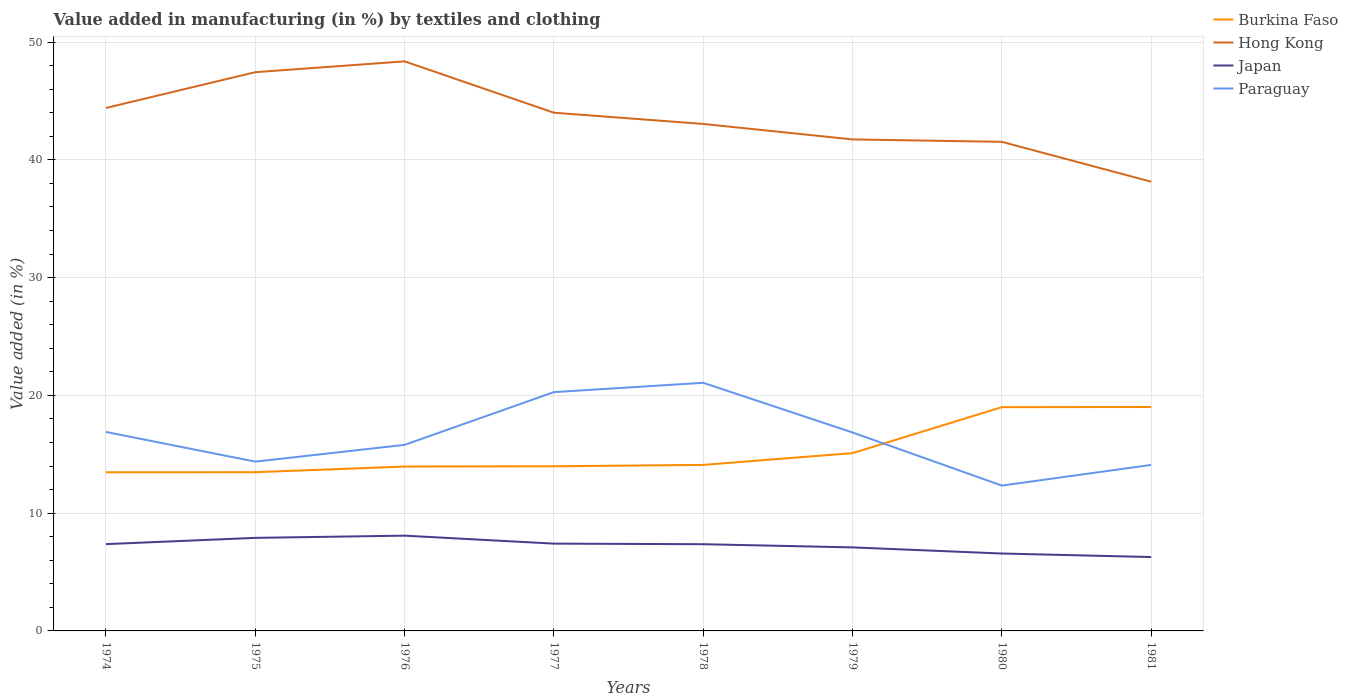How many different coloured lines are there?
Give a very brief answer. 4. Does the line corresponding to Hong Kong intersect with the line corresponding to Japan?
Provide a succinct answer. No. Across all years, what is the maximum percentage of value added in manufacturing by textiles and clothing in Paraguay?
Keep it short and to the point. 12.34. What is the total percentage of value added in manufacturing by textiles and clothing in Burkina Faso in the graph?
Keep it short and to the point. -5.53. What is the difference between the highest and the second highest percentage of value added in manufacturing by textiles and clothing in Hong Kong?
Your response must be concise. 10.22. What is the difference between the highest and the lowest percentage of value added in manufacturing by textiles and clothing in Hong Kong?
Offer a very short reply. 4. Is the percentage of value added in manufacturing by textiles and clothing in Japan strictly greater than the percentage of value added in manufacturing by textiles and clothing in Hong Kong over the years?
Your response must be concise. Yes. How many lines are there?
Provide a short and direct response. 4. How many years are there in the graph?
Make the answer very short. 8. What is the difference between two consecutive major ticks on the Y-axis?
Your answer should be compact. 10. Are the values on the major ticks of Y-axis written in scientific E-notation?
Give a very brief answer. No. How are the legend labels stacked?
Provide a short and direct response. Vertical. What is the title of the graph?
Make the answer very short. Value added in manufacturing (in %) by textiles and clothing. Does "Lower middle income" appear as one of the legend labels in the graph?
Offer a terse response. No. What is the label or title of the X-axis?
Your response must be concise. Years. What is the label or title of the Y-axis?
Offer a very short reply. Value added (in %). What is the Value added (in %) of Burkina Faso in 1974?
Keep it short and to the point. 13.47. What is the Value added (in %) in Hong Kong in 1974?
Provide a short and direct response. 44.41. What is the Value added (in %) of Japan in 1974?
Your answer should be very brief. 7.37. What is the Value added (in %) in Paraguay in 1974?
Keep it short and to the point. 16.9. What is the Value added (in %) of Burkina Faso in 1975?
Give a very brief answer. 13.48. What is the Value added (in %) in Hong Kong in 1975?
Offer a terse response. 47.44. What is the Value added (in %) of Japan in 1975?
Your answer should be very brief. 7.9. What is the Value added (in %) in Paraguay in 1975?
Provide a short and direct response. 14.38. What is the Value added (in %) in Burkina Faso in 1976?
Keep it short and to the point. 13.96. What is the Value added (in %) of Hong Kong in 1976?
Give a very brief answer. 48.36. What is the Value added (in %) in Japan in 1976?
Your response must be concise. 8.09. What is the Value added (in %) in Paraguay in 1976?
Your answer should be very brief. 15.8. What is the Value added (in %) of Burkina Faso in 1977?
Ensure brevity in your answer.  13.98. What is the Value added (in %) in Hong Kong in 1977?
Your answer should be compact. 44. What is the Value added (in %) of Japan in 1977?
Ensure brevity in your answer.  7.41. What is the Value added (in %) of Paraguay in 1977?
Ensure brevity in your answer.  20.28. What is the Value added (in %) of Burkina Faso in 1978?
Your answer should be very brief. 14.1. What is the Value added (in %) of Hong Kong in 1978?
Offer a terse response. 43.05. What is the Value added (in %) of Japan in 1978?
Offer a very short reply. 7.36. What is the Value added (in %) of Paraguay in 1978?
Keep it short and to the point. 21.07. What is the Value added (in %) in Burkina Faso in 1979?
Offer a terse response. 15.1. What is the Value added (in %) in Hong Kong in 1979?
Your response must be concise. 41.74. What is the Value added (in %) in Japan in 1979?
Your response must be concise. 7.09. What is the Value added (in %) in Paraguay in 1979?
Provide a succinct answer. 16.85. What is the Value added (in %) in Burkina Faso in 1980?
Offer a very short reply. 19. What is the Value added (in %) in Hong Kong in 1980?
Keep it short and to the point. 41.53. What is the Value added (in %) of Japan in 1980?
Provide a short and direct response. 6.57. What is the Value added (in %) in Paraguay in 1980?
Provide a succinct answer. 12.34. What is the Value added (in %) in Burkina Faso in 1981?
Keep it short and to the point. 19.01. What is the Value added (in %) in Hong Kong in 1981?
Provide a short and direct response. 38.15. What is the Value added (in %) of Japan in 1981?
Your response must be concise. 6.27. What is the Value added (in %) of Paraguay in 1981?
Your answer should be compact. 14.1. Across all years, what is the maximum Value added (in %) of Burkina Faso?
Ensure brevity in your answer.  19.01. Across all years, what is the maximum Value added (in %) of Hong Kong?
Your answer should be very brief. 48.36. Across all years, what is the maximum Value added (in %) of Japan?
Offer a very short reply. 8.09. Across all years, what is the maximum Value added (in %) in Paraguay?
Ensure brevity in your answer.  21.07. Across all years, what is the minimum Value added (in %) in Burkina Faso?
Offer a terse response. 13.47. Across all years, what is the minimum Value added (in %) in Hong Kong?
Provide a succinct answer. 38.15. Across all years, what is the minimum Value added (in %) of Japan?
Offer a terse response. 6.27. Across all years, what is the minimum Value added (in %) of Paraguay?
Provide a short and direct response. 12.34. What is the total Value added (in %) in Burkina Faso in the graph?
Ensure brevity in your answer.  122.1. What is the total Value added (in %) of Hong Kong in the graph?
Provide a short and direct response. 348.69. What is the total Value added (in %) of Japan in the graph?
Provide a succinct answer. 58.08. What is the total Value added (in %) of Paraguay in the graph?
Keep it short and to the point. 131.71. What is the difference between the Value added (in %) of Burkina Faso in 1974 and that in 1975?
Provide a succinct answer. -0. What is the difference between the Value added (in %) of Hong Kong in 1974 and that in 1975?
Provide a succinct answer. -3.04. What is the difference between the Value added (in %) in Japan in 1974 and that in 1975?
Give a very brief answer. -0.53. What is the difference between the Value added (in %) of Paraguay in 1974 and that in 1975?
Make the answer very short. 2.52. What is the difference between the Value added (in %) of Burkina Faso in 1974 and that in 1976?
Your answer should be very brief. -0.48. What is the difference between the Value added (in %) of Hong Kong in 1974 and that in 1976?
Your response must be concise. -3.96. What is the difference between the Value added (in %) of Japan in 1974 and that in 1976?
Keep it short and to the point. -0.72. What is the difference between the Value added (in %) of Paraguay in 1974 and that in 1976?
Offer a terse response. 1.1. What is the difference between the Value added (in %) in Burkina Faso in 1974 and that in 1977?
Keep it short and to the point. -0.51. What is the difference between the Value added (in %) in Hong Kong in 1974 and that in 1977?
Your answer should be compact. 0.4. What is the difference between the Value added (in %) of Japan in 1974 and that in 1977?
Provide a short and direct response. -0.04. What is the difference between the Value added (in %) in Paraguay in 1974 and that in 1977?
Your answer should be very brief. -3.38. What is the difference between the Value added (in %) of Burkina Faso in 1974 and that in 1978?
Keep it short and to the point. -0.62. What is the difference between the Value added (in %) in Hong Kong in 1974 and that in 1978?
Your answer should be compact. 1.36. What is the difference between the Value added (in %) in Japan in 1974 and that in 1978?
Give a very brief answer. 0.01. What is the difference between the Value added (in %) of Paraguay in 1974 and that in 1978?
Give a very brief answer. -4.17. What is the difference between the Value added (in %) in Burkina Faso in 1974 and that in 1979?
Make the answer very short. -1.62. What is the difference between the Value added (in %) in Hong Kong in 1974 and that in 1979?
Give a very brief answer. 2.67. What is the difference between the Value added (in %) of Japan in 1974 and that in 1979?
Offer a terse response. 0.28. What is the difference between the Value added (in %) of Paraguay in 1974 and that in 1979?
Provide a short and direct response. 0.05. What is the difference between the Value added (in %) in Burkina Faso in 1974 and that in 1980?
Your answer should be compact. -5.53. What is the difference between the Value added (in %) of Hong Kong in 1974 and that in 1980?
Provide a short and direct response. 2.88. What is the difference between the Value added (in %) in Japan in 1974 and that in 1980?
Keep it short and to the point. 0.8. What is the difference between the Value added (in %) in Paraguay in 1974 and that in 1980?
Provide a succinct answer. 4.55. What is the difference between the Value added (in %) in Burkina Faso in 1974 and that in 1981?
Your response must be concise. -5.54. What is the difference between the Value added (in %) in Hong Kong in 1974 and that in 1981?
Your answer should be compact. 6.26. What is the difference between the Value added (in %) in Japan in 1974 and that in 1981?
Your answer should be very brief. 1.1. What is the difference between the Value added (in %) of Paraguay in 1974 and that in 1981?
Provide a short and direct response. 2.8. What is the difference between the Value added (in %) of Burkina Faso in 1975 and that in 1976?
Offer a terse response. -0.48. What is the difference between the Value added (in %) in Hong Kong in 1975 and that in 1976?
Offer a terse response. -0.92. What is the difference between the Value added (in %) in Japan in 1975 and that in 1976?
Offer a very short reply. -0.19. What is the difference between the Value added (in %) in Paraguay in 1975 and that in 1976?
Provide a short and direct response. -1.42. What is the difference between the Value added (in %) in Burkina Faso in 1975 and that in 1977?
Offer a very short reply. -0.5. What is the difference between the Value added (in %) of Hong Kong in 1975 and that in 1977?
Keep it short and to the point. 3.44. What is the difference between the Value added (in %) of Japan in 1975 and that in 1977?
Ensure brevity in your answer.  0.49. What is the difference between the Value added (in %) of Paraguay in 1975 and that in 1977?
Offer a very short reply. -5.9. What is the difference between the Value added (in %) in Burkina Faso in 1975 and that in 1978?
Keep it short and to the point. -0.62. What is the difference between the Value added (in %) in Hong Kong in 1975 and that in 1978?
Keep it short and to the point. 4.39. What is the difference between the Value added (in %) of Japan in 1975 and that in 1978?
Keep it short and to the point. 0.54. What is the difference between the Value added (in %) in Paraguay in 1975 and that in 1978?
Your response must be concise. -6.69. What is the difference between the Value added (in %) in Burkina Faso in 1975 and that in 1979?
Offer a very short reply. -1.62. What is the difference between the Value added (in %) of Hong Kong in 1975 and that in 1979?
Offer a very short reply. 5.71. What is the difference between the Value added (in %) in Japan in 1975 and that in 1979?
Make the answer very short. 0.81. What is the difference between the Value added (in %) in Paraguay in 1975 and that in 1979?
Your answer should be very brief. -2.48. What is the difference between the Value added (in %) of Burkina Faso in 1975 and that in 1980?
Give a very brief answer. -5.52. What is the difference between the Value added (in %) in Hong Kong in 1975 and that in 1980?
Your answer should be compact. 5.91. What is the difference between the Value added (in %) of Japan in 1975 and that in 1980?
Provide a short and direct response. 1.33. What is the difference between the Value added (in %) in Paraguay in 1975 and that in 1980?
Offer a terse response. 2.03. What is the difference between the Value added (in %) in Burkina Faso in 1975 and that in 1981?
Provide a succinct answer. -5.54. What is the difference between the Value added (in %) in Hong Kong in 1975 and that in 1981?
Your response must be concise. 9.3. What is the difference between the Value added (in %) of Japan in 1975 and that in 1981?
Provide a short and direct response. 1.63. What is the difference between the Value added (in %) of Paraguay in 1975 and that in 1981?
Provide a succinct answer. 0.28. What is the difference between the Value added (in %) of Burkina Faso in 1976 and that in 1977?
Your response must be concise. -0.02. What is the difference between the Value added (in %) in Hong Kong in 1976 and that in 1977?
Provide a short and direct response. 4.36. What is the difference between the Value added (in %) of Japan in 1976 and that in 1977?
Make the answer very short. 0.68. What is the difference between the Value added (in %) of Paraguay in 1976 and that in 1977?
Your answer should be very brief. -4.48. What is the difference between the Value added (in %) of Burkina Faso in 1976 and that in 1978?
Keep it short and to the point. -0.14. What is the difference between the Value added (in %) of Hong Kong in 1976 and that in 1978?
Your answer should be compact. 5.31. What is the difference between the Value added (in %) in Japan in 1976 and that in 1978?
Ensure brevity in your answer.  0.73. What is the difference between the Value added (in %) of Paraguay in 1976 and that in 1978?
Keep it short and to the point. -5.27. What is the difference between the Value added (in %) in Burkina Faso in 1976 and that in 1979?
Offer a very short reply. -1.14. What is the difference between the Value added (in %) of Hong Kong in 1976 and that in 1979?
Make the answer very short. 6.63. What is the difference between the Value added (in %) of Japan in 1976 and that in 1979?
Your answer should be very brief. 1. What is the difference between the Value added (in %) in Paraguay in 1976 and that in 1979?
Your answer should be compact. -1.05. What is the difference between the Value added (in %) in Burkina Faso in 1976 and that in 1980?
Make the answer very short. -5.04. What is the difference between the Value added (in %) of Hong Kong in 1976 and that in 1980?
Your response must be concise. 6.83. What is the difference between the Value added (in %) in Japan in 1976 and that in 1980?
Keep it short and to the point. 1.52. What is the difference between the Value added (in %) in Paraguay in 1976 and that in 1980?
Offer a very short reply. 3.46. What is the difference between the Value added (in %) of Burkina Faso in 1976 and that in 1981?
Your response must be concise. -5.06. What is the difference between the Value added (in %) in Hong Kong in 1976 and that in 1981?
Your answer should be very brief. 10.22. What is the difference between the Value added (in %) in Japan in 1976 and that in 1981?
Give a very brief answer. 1.82. What is the difference between the Value added (in %) in Paraguay in 1976 and that in 1981?
Your answer should be compact. 1.7. What is the difference between the Value added (in %) in Burkina Faso in 1977 and that in 1978?
Offer a terse response. -0.12. What is the difference between the Value added (in %) of Hong Kong in 1977 and that in 1978?
Your answer should be very brief. 0.95. What is the difference between the Value added (in %) in Japan in 1977 and that in 1978?
Your response must be concise. 0.05. What is the difference between the Value added (in %) in Paraguay in 1977 and that in 1978?
Provide a succinct answer. -0.79. What is the difference between the Value added (in %) of Burkina Faso in 1977 and that in 1979?
Your answer should be very brief. -1.12. What is the difference between the Value added (in %) of Hong Kong in 1977 and that in 1979?
Your response must be concise. 2.27. What is the difference between the Value added (in %) of Japan in 1977 and that in 1979?
Offer a terse response. 0.32. What is the difference between the Value added (in %) in Paraguay in 1977 and that in 1979?
Ensure brevity in your answer.  3.43. What is the difference between the Value added (in %) in Burkina Faso in 1977 and that in 1980?
Your answer should be very brief. -5.02. What is the difference between the Value added (in %) of Hong Kong in 1977 and that in 1980?
Offer a very short reply. 2.47. What is the difference between the Value added (in %) in Japan in 1977 and that in 1980?
Provide a succinct answer. 0.84. What is the difference between the Value added (in %) in Paraguay in 1977 and that in 1980?
Provide a short and direct response. 7.94. What is the difference between the Value added (in %) of Burkina Faso in 1977 and that in 1981?
Make the answer very short. -5.03. What is the difference between the Value added (in %) in Hong Kong in 1977 and that in 1981?
Offer a very short reply. 5.86. What is the difference between the Value added (in %) in Japan in 1977 and that in 1981?
Offer a terse response. 1.14. What is the difference between the Value added (in %) of Paraguay in 1977 and that in 1981?
Make the answer very short. 6.18. What is the difference between the Value added (in %) of Burkina Faso in 1978 and that in 1979?
Make the answer very short. -1. What is the difference between the Value added (in %) of Hong Kong in 1978 and that in 1979?
Ensure brevity in your answer.  1.32. What is the difference between the Value added (in %) of Japan in 1978 and that in 1979?
Offer a terse response. 0.27. What is the difference between the Value added (in %) in Paraguay in 1978 and that in 1979?
Your answer should be compact. 4.22. What is the difference between the Value added (in %) of Burkina Faso in 1978 and that in 1980?
Your answer should be very brief. -4.9. What is the difference between the Value added (in %) of Hong Kong in 1978 and that in 1980?
Your answer should be compact. 1.52. What is the difference between the Value added (in %) of Japan in 1978 and that in 1980?
Give a very brief answer. 0.79. What is the difference between the Value added (in %) in Paraguay in 1978 and that in 1980?
Your response must be concise. 8.73. What is the difference between the Value added (in %) in Burkina Faso in 1978 and that in 1981?
Give a very brief answer. -4.92. What is the difference between the Value added (in %) of Hong Kong in 1978 and that in 1981?
Provide a succinct answer. 4.9. What is the difference between the Value added (in %) of Japan in 1978 and that in 1981?
Your answer should be very brief. 1.09. What is the difference between the Value added (in %) of Paraguay in 1978 and that in 1981?
Provide a succinct answer. 6.97. What is the difference between the Value added (in %) in Burkina Faso in 1979 and that in 1980?
Your answer should be compact. -3.9. What is the difference between the Value added (in %) of Hong Kong in 1979 and that in 1980?
Your answer should be compact. 0.2. What is the difference between the Value added (in %) of Japan in 1979 and that in 1980?
Offer a terse response. 0.52. What is the difference between the Value added (in %) in Paraguay in 1979 and that in 1980?
Offer a terse response. 4.51. What is the difference between the Value added (in %) in Burkina Faso in 1979 and that in 1981?
Your answer should be compact. -3.92. What is the difference between the Value added (in %) in Hong Kong in 1979 and that in 1981?
Keep it short and to the point. 3.59. What is the difference between the Value added (in %) in Japan in 1979 and that in 1981?
Your answer should be compact. 0.82. What is the difference between the Value added (in %) of Paraguay in 1979 and that in 1981?
Your answer should be very brief. 2.75. What is the difference between the Value added (in %) of Burkina Faso in 1980 and that in 1981?
Give a very brief answer. -0.01. What is the difference between the Value added (in %) in Hong Kong in 1980 and that in 1981?
Ensure brevity in your answer.  3.38. What is the difference between the Value added (in %) in Japan in 1980 and that in 1981?
Provide a succinct answer. 0.3. What is the difference between the Value added (in %) in Paraguay in 1980 and that in 1981?
Keep it short and to the point. -1.75. What is the difference between the Value added (in %) in Burkina Faso in 1974 and the Value added (in %) in Hong Kong in 1975?
Ensure brevity in your answer.  -33.97. What is the difference between the Value added (in %) of Burkina Faso in 1974 and the Value added (in %) of Japan in 1975?
Give a very brief answer. 5.57. What is the difference between the Value added (in %) of Burkina Faso in 1974 and the Value added (in %) of Paraguay in 1975?
Your response must be concise. -0.9. What is the difference between the Value added (in %) in Hong Kong in 1974 and the Value added (in %) in Japan in 1975?
Keep it short and to the point. 36.5. What is the difference between the Value added (in %) in Hong Kong in 1974 and the Value added (in %) in Paraguay in 1975?
Make the answer very short. 30.03. What is the difference between the Value added (in %) of Japan in 1974 and the Value added (in %) of Paraguay in 1975?
Offer a terse response. -7.01. What is the difference between the Value added (in %) in Burkina Faso in 1974 and the Value added (in %) in Hong Kong in 1976?
Offer a very short reply. -34.89. What is the difference between the Value added (in %) in Burkina Faso in 1974 and the Value added (in %) in Japan in 1976?
Provide a short and direct response. 5.38. What is the difference between the Value added (in %) of Burkina Faso in 1974 and the Value added (in %) of Paraguay in 1976?
Make the answer very short. -2.32. What is the difference between the Value added (in %) in Hong Kong in 1974 and the Value added (in %) in Japan in 1976?
Provide a short and direct response. 36.32. What is the difference between the Value added (in %) of Hong Kong in 1974 and the Value added (in %) of Paraguay in 1976?
Your answer should be compact. 28.61. What is the difference between the Value added (in %) in Japan in 1974 and the Value added (in %) in Paraguay in 1976?
Give a very brief answer. -8.43. What is the difference between the Value added (in %) of Burkina Faso in 1974 and the Value added (in %) of Hong Kong in 1977?
Ensure brevity in your answer.  -30.53. What is the difference between the Value added (in %) of Burkina Faso in 1974 and the Value added (in %) of Japan in 1977?
Your answer should be compact. 6.06. What is the difference between the Value added (in %) in Burkina Faso in 1974 and the Value added (in %) in Paraguay in 1977?
Offer a terse response. -6.8. What is the difference between the Value added (in %) in Hong Kong in 1974 and the Value added (in %) in Japan in 1977?
Give a very brief answer. 36.99. What is the difference between the Value added (in %) in Hong Kong in 1974 and the Value added (in %) in Paraguay in 1977?
Ensure brevity in your answer.  24.13. What is the difference between the Value added (in %) in Japan in 1974 and the Value added (in %) in Paraguay in 1977?
Ensure brevity in your answer.  -12.91. What is the difference between the Value added (in %) of Burkina Faso in 1974 and the Value added (in %) of Hong Kong in 1978?
Keep it short and to the point. -29.58. What is the difference between the Value added (in %) in Burkina Faso in 1974 and the Value added (in %) in Japan in 1978?
Ensure brevity in your answer.  6.11. What is the difference between the Value added (in %) in Burkina Faso in 1974 and the Value added (in %) in Paraguay in 1978?
Provide a short and direct response. -7.6. What is the difference between the Value added (in %) of Hong Kong in 1974 and the Value added (in %) of Japan in 1978?
Your answer should be very brief. 37.04. What is the difference between the Value added (in %) in Hong Kong in 1974 and the Value added (in %) in Paraguay in 1978?
Ensure brevity in your answer.  23.34. What is the difference between the Value added (in %) of Japan in 1974 and the Value added (in %) of Paraguay in 1978?
Ensure brevity in your answer.  -13.7. What is the difference between the Value added (in %) of Burkina Faso in 1974 and the Value added (in %) of Hong Kong in 1979?
Offer a very short reply. -28.26. What is the difference between the Value added (in %) of Burkina Faso in 1974 and the Value added (in %) of Japan in 1979?
Provide a succinct answer. 6.38. What is the difference between the Value added (in %) of Burkina Faso in 1974 and the Value added (in %) of Paraguay in 1979?
Ensure brevity in your answer.  -3.38. What is the difference between the Value added (in %) in Hong Kong in 1974 and the Value added (in %) in Japan in 1979?
Give a very brief answer. 37.31. What is the difference between the Value added (in %) of Hong Kong in 1974 and the Value added (in %) of Paraguay in 1979?
Provide a succinct answer. 27.56. What is the difference between the Value added (in %) of Japan in 1974 and the Value added (in %) of Paraguay in 1979?
Your answer should be compact. -9.48. What is the difference between the Value added (in %) of Burkina Faso in 1974 and the Value added (in %) of Hong Kong in 1980?
Provide a succinct answer. -28.06. What is the difference between the Value added (in %) of Burkina Faso in 1974 and the Value added (in %) of Japan in 1980?
Give a very brief answer. 6.9. What is the difference between the Value added (in %) of Burkina Faso in 1974 and the Value added (in %) of Paraguay in 1980?
Provide a short and direct response. 1.13. What is the difference between the Value added (in %) of Hong Kong in 1974 and the Value added (in %) of Japan in 1980?
Keep it short and to the point. 37.83. What is the difference between the Value added (in %) in Hong Kong in 1974 and the Value added (in %) in Paraguay in 1980?
Provide a succinct answer. 32.07. What is the difference between the Value added (in %) of Japan in 1974 and the Value added (in %) of Paraguay in 1980?
Offer a terse response. -4.97. What is the difference between the Value added (in %) in Burkina Faso in 1974 and the Value added (in %) in Hong Kong in 1981?
Give a very brief answer. -24.67. What is the difference between the Value added (in %) of Burkina Faso in 1974 and the Value added (in %) of Japan in 1981?
Your response must be concise. 7.2. What is the difference between the Value added (in %) of Burkina Faso in 1974 and the Value added (in %) of Paraguay in 1981?
Provide a succinct answer. -0.62. What is the difference between the Value added (in %) in Hong Kong in 1974 and the Value added (in %) in Japan in 1981?
Offer a very short reply. 38.13. What is the difference between the Value added (in %) of Hong Kong in 1974 and the Value added (in %) of Paraguay in 1981?
Ensure brevity in your answer.  30.31. What is the difference between the Value added (in %) of Japan in 1974 and the Value added (in %) of Paraguay in 1981?
Provide a short and direct response. -6.73. What is the difference between the Value added (in %) of Burkina Faso in 1975 and the Value added (in %) of Hong Kong in 1976?
Make the answer very short. -34.89. What is the difference between the Value added (in %) of Burkina Faso in 1975 and the Value added (in %) of Japan in 1976?
Keep it short and to the point. 5.39. What is the difference between the Value added (in %) in Burkina Faso in 1975 and the Value added (in %) in Paraguay in 1976?
Offer a very short reply. -2.32. What is the difference between the Value added (in %) in Hong Kong in 1975 and the Value added (in %) in Japan in 1976?
Make the answer very short. 39.36. What is the difference between the Value added (in %) of Hong Kong in 1975 and the Value added (in %) of Paraguay in 1976?
Provide a short and direct response. 31.65. What is the difference between the Value added (in %) in Japan in 1975 and the Value added (in %) in Paraguay in 1976?
Give a very brief answer. -7.9. What is the difference between the Value added (in %) of Burkina Faso in 1975 and the Value added (in %) of Hong Kong in 1977?
Offer a terse response. -30.53. What is the difference between the Value added (in %) in Burkina Faso in 1975 and the Value added (in %) in Japan in 1977?
Your answer should be compact. 6.07. What is the difference between the Value added (in %) in Burkina Faso in 1975 and the Value added (in %) in Paraguay in 1977?
Offer a terse response. -6.8. What is the difference between the Value added (in %) of Hong Kong in 1975 and the Value added (in %) of Japan in 1977?
Your answer should be compact. 40.03. What is the difference between the Value added (in %) of Hong Kong in 1975 and the Value added (in %) of Paraguay in 1977?
Give a very brief answer. 27.17. What is the difference between the Value added (in %) in Japan in 1975 and the Value added (in %) in Paraguay in 1977?
Offer a terse response. -12.38. What is the difference between the Value added (in %) of Burkina Faso in 1975 and the Value added (in %) of Hong Kong in 1978?
Offer a very short reply. -29.57. What is the difference between the Value added (in %) in Burkina Faso in 1975 and the Value added (in %) in Japan in 1978?
Provide a short and direct response. 6.12. What is the difference between the Value added (in %) of Burkina Faso in 1975 and the Value added (in %) of Paraguay in 1978?
Keep it short and to the point. -7.59. What is the difference between the Value added (in %) in Hong Kong in 1975 and the Value added (in %) in Japan in 1978?
Your response must be concise. 40.08. What is the difference between the Value added (in %) of Hong Kong in 1975 and the Value added (in %) of Paraguay in 1978?
Ensure brevity in your answer.  26.38. What is the difference between the Value added (in %) of Japan in 1975 and the Value added (in %) of Paraguay in 1978?
Give a very brief answer. -13.17. What is the difference between the Value added (in %) in Burkina Faso in 1975 and the Value added (in %) in Hong Kong in 1979?
Your response must be concise. -28.26. What is the difference between the Value added (in %) in Burkina Faso in 1975 and the Value added (in %) in Japan in 1979?
Give a very brief answer. 6.39. What is the difference between the Value added (in %) in Burkina Faso in 1975 and the Value added (in %) in Paraguay in 1979?
Ensure brevity in your answer.  -3.37. What is the difference between the Value added (in %) of Hong Kong in 1975 and the Value added (in %) of Japan in 1979?
Provide a short and direct response. 40.35. What is the difference between the Value added (in %) of Hong Kong in 1975 and the Value added (in %) of Paraguay in 1979?
Give a very brief answer. 30.59. What is the difference between the Value added (in %) in Japan in 1975 and the Value added (in %) in Paraguay in 1979?
Provide a short and direct response. -8.95. What is the difference between the Value added (in %) in Burkina Faso in 1975 and the Value added (in %) in Hong Kong in 1980?
Offer a terse response. -28.05. What is the difference between the Value added (in %) of Burkina Faso in 1975 and the Value added (in %) of Japan in 1980?
Give a very brief answer. 6.91. What is the difference between the Value added (in %) of Burkina Faso in 1975 and the Value added (in %) of Paraguay in 1980?
Give a very brief answer. 1.14. What is the difference between the Value added (in %) of Hong Kong in 1975 and the Value added (in %) of Japan in 1980?
Ensure brevity in your answer.  40.87. What is the difference between the Value added (in %) in Hong Kong in 1975 and the Value added (in %) in Paraguay in 1980?
Make the answer very short. 35.1. What is the difference between the Value added (in %) of Japan in 1975 and the Value added (in %) of Paraguay in 1980?
Provide a succinct answer. -4.44. What is the difference between the Value added (in %) in Burkina Faso in 1975 and the Value added (in %) in Hong Kong in 1981?
Provide a succinct answer. -24.67. What is the difference between the Value added (in %) of Burkina Faso in 1975 and the Value added (in %) of Japan in 1981?
Offer a terse response. 7.21. What is the difference between the Value added (in %) in Burkina Faso in 1975 and the Value added (in %) in Paraguay in 1981?
Ensure brevity in your answer.  -0.62. What is the difference between the Value added (in %) in Hong Kong in 1975 and the Value added (in %) in Japan in 1981?
Your answer should be compact. 41.17. What is the difference between the Value added (in %) in Hong Kong in 1975 and the Value added (in %) in Paraguay in 1981?
Ensure brevity in your answer.  33.35. What is the difference between the Value added (in %) in Japan in 1975 and the Value added (in %) in Paraguay in 1981?
Your answer should be very brief. -6.19. What is the difference between the Value added (in %) in Burkina Faso in 1976 and the Value added (in %) in Hong Kong in 1977?
Ensure brevity in your answer.  -30.05. What is the difference between the Value added (in %) of Burkina Faso in 1976 and the Value added (in %) of Japan in 1977?
Your response must be concise. 6.55. What is the difference between the Value added (in %) in Burkina Faso in 1976 and the Value added (in %) in Paraguay in 1977?
Offer a very short reply. -6.32. What is the difference between the Value added (in %) in Hong Kong in 1976 and the Value added (in %) in Japan in 1977?
Your answer should be very brief. 40.95. What is the difference between the Value added (in %) of Hong Kong in 1976 and the Value added (in %) of Paraguay in 1977?
Your answer should be compact. 28.09. What is the difference between the Value added (in %) of Japan in 1976 and the Value added (in %) of Paraguay in 1977?
Give a very brief answer. -12.19. What is the difference between the Value added (in %) of Burkina Faso in 1976 and the Value added (in %) of Hong Kong in 1978?
Provide a succinct answer. -29.09. What is the difference between the Value added (in %) of Burkina Faso in 1976 and the Value added (in %) of Japan in 1978?
Keep it short and to the point. 6.59. What is the difference between the Value added (in %) of Burkina Faso in 1976 and the Value added (in %) of Paraguay in 1978?
Provide a succinct answer. -7.11. What is the difference between the Value added (in %) of Hong Kong in 1976 and the Value added (in %) of Japan in 1978?
Offer a terse response. 41. What is the difference between the Value added (in %) in Hong Kong in 1976 and the Value added (in %) in Paraguay in 1978?
Your answer should be very brief. 27.3. What is the difference between the Value added (in %) in Japan in 1976 and the Value added (in %) in Paraguay in 1978?
Ensure brevity in your answer.  -12.98. What is the difference between the Value added (in %) of Burkina Faso in 1976 and the Value added (in %) of Hong Kong in 1979?
Ensure brevity in your answer.  -27.78. What is the difference between the Value added (in %) of Burkina Faso in 1976 and the Value added (in %) of Japan in 1979?
Provide a short and direct response. 6.86. What is the difference between the Value added (in %) in Burkina Faso in 1976 and the Value added (in %) in Paraguay in 1979?
Keep it short and to the point. -2.89. What is the difference between the Value added (in %) in Hong Kong in 1976 and the Value added (in %) in Japan in 1979?
Give a very brief answer. 41.27. What is the difference between the Value added (in %) in Hong Kong in 1976 and the Value added (in %) in Paraguay in 1979?
Ensure brevity in your answer.  31.51. What is the difference between the Value added (in %) in Japan in 1976 and the Value added (in %) in Paraguay in 1979?
Provide a succinct answer. -8.76. What is the difference between the Value added (in %) in Burkina Faso in 1976 and the Value added (in %) in Hong Kong in 1980?
Your response must be concise. -27.57. What is the difference between the Value added (in %) of Burkina Faso in 1976 and the Value added (in %) of Japan in 1980?
Offer a very short reply. 7.38. What is the difference between the Value added (in %) in Burkina Faso in 1976 and the Value added (in %) in Paraguay in 1980?
Offer a very short reply. 1.62. What is the difference between the Value added (in %) in Hong Kong in 1976 and the Value added (in %) in Japan in 1980?
Offer a terse response. 41.79. What is the difference between the Value added (in %) of Hong Kong in 1976 and the Value added (in %) of Paraguay in 1980?
Offer a terse response. 36.02. What is the difference between the Value added (in %) in Japan in 1976 and the Value added (in %) in Paraguay in 1980?
Offer a terse response. -4.25. What is the difference between the Value added (in %) of Burkina Faso in 1976 and the Value added (in %) of Hong Kong in 1981?
Give a very brief answer. -24.19. What is the difference between the Value added (in %) in Burkina Faso in 1976 and the Value added (in %) in Japan in 1981?
Offer a very short reply. 7.69. What is the difference between the Value added (in %) of Burkina Faso in 1976 and the Value added (in %) of Paraguay in 1981?
Give a very brief answer. -0.14. What is the difference between the Value added (in %) in Hong Kong in 1976 and the Value added (in %) in Japan in 1981?
Your answer should be compact. 42.09. What is the difference between the Value added (in %) in Hong Kong in 1976 and the Value added (in %) in Paraguay in 1981?
Make the answer very short. 34.27. What is the difference between the Value added (in %) in Japan in 1976 and the Value added (in %) in Paraguay in 1981?
Keep it short and to the point. -6.01. What is the difference between the Value added (in %) of Burkina Faso in 1977 and the Value added (in %) of Hong Kong in 1978?
Your response must be concise. -29.07. What is the difference between the Value added (in %) in Burkina Faso in 1977 and the Value added (in %) in Japan in 1978?
Offer a terse response. 6.62. What is the difference between the Value added (in %) of Burkina Faso in 1977 and the Value added (in %) of Paraguay in 1978?
Offer a terse response. -7.09. What is the difference between the Value added (in %) in Hong Kong in 1977 and the Value added (in %) in Japan in 1978?
Your answer should be very brief. 36.64. What is the difference between the Value added (in %) of Hong Kong in 1977 and the Value added (in %) of Paraguay in 1978?
Your answer should be compact. 22.93. What is the difference between the Value added (in %) in Japan in 1977 and the Value added (in %) in Paraguay in 1978?
Provide a succinct answer. -13.66. What is the difference between the Value added (in %) of Burkina Faso in 1977 and the Value added (in %) of Hong Kong in 1979?
Your response must be concise. -27.75. What is the difference between the Value added (in %) in Burkina Faso in 1977 and the Value added (in %) in Japan in 1979?
Give a very brief answer. 6.89. What is the difference between the Value added (in %) in Burkina Faso in 1977 and the Value added (in %) in Paraguay in 1979?
Give a very brief answer. -2.87. What is the difference between the Value added (in %) of Hong Kong in 1977 and the Value added (in %) of Japan in 1979?
Offer a terse response. 36.91. What is the difference between the Value added (in %) in Hong Kong in 1977 and the Value added (in %) in Paraguay in 1979?
Ensure brevity in your answer.  27.15. What is the difference between the Value added (in %) of Japan in 1977 and the Value added (in %) of Paraguay in 1979?
Offer a very short reply. -9.44. What is the difference between the Value added (in %) of Burkina Faso in 1977 and the Value added (in %) of Hong Kong in 1980?
Make the answer very short. -27.55. What is the difference between the Value added (in %) of Burkina Faso in 1977 and the Value added (in %) of Japan in 1980?
Offer a terse response. 7.41. What is the difference between the Value added (in %) in Burkina Faso in 1977 and the Value added (in %) in Paraguay in 1980?
Your answer should be very brief. 1.64. What is the difference between the Value added (in %) in Hong Kong in 1977 and the Value added (in %) in Japan in 1980?
Your response must be concise. 37.43. What is the difference between the Value added (in %) of Hong Kong in 1977 and the Value added (in %) of Paraguay in 1980?
Your answer should be very brief. 31.66. What is the difference between the Value added (in %) of Japan in 1977 and the Value added (in %) of Paraguay in 1980?
Your answer should be very brief. -4.93. What is the difference between the Value added (in %) of Burkina Faso in 1977 and the Value added (in %) of Hong Kong in 1981?
Offer a terse response. -24.17. What is the difference between the Value added (in %) of Burkina Faso in 1977 and the Value added (in %) of Japan in 1981?
Offer a terse response. 7.71. What is the difference between the Value added (in %) in Burkina Faso in 1977 and the Value added (in %) in Paraguay in 1981?
Keep it short and to the point. -0.11. What is the difference between the Value added (in %) in Hong Kong in 1977 and the Value added (in %) in Japan in 1981?
Ensure brevity in your answer.  37.73. What is the difference between the Value added (in %) of Hong Kong in 1977 and the Value added (in %) of Paraguay in 1981?
Offer a terse response. 29.91. What is the difference between the Value added (in %) in Japan in 1977 and the Value added (in %) in Paraguay in 1981?
Your response must be concise. -6.68. What is the difference between the Value added (in %) in Burkina Faso in 1978 and the Value added (in %) in Hong Kong in 1979?
Offer a very short reply. -27.64. What is the difference between the Value added (in %) of Burkina Faso in 1978 and the Value added (in %) of Japan in 1979?
Ensure brevity in your answer.  7. What is the difference between the Value added (in %) in Burkina Faso in 1978 and the Value added (in %) in Paraguay in 1979?
Make the answer very short. -2.75. What is the difference between the Value added (in %) of Hong Kong in 1978 and the Value added (in %) of Japan in 1979?
Offer a terse response. 35.96. What is the difference between the Value added (in %) in Hong Kong in 1978 and the Value added (in %) in Paraguay in 1979?
Give a very brief answer. 26.2. What is the difference between the Value added (in %) in Japan in 1978 and the Value added (in %) in Paraguay in 1979?
Provide a succinct answer. -9.49. What is the difference between the Value added (in %) of Burkina Faso in 1978 and the Value added (in %) of Hong Kong in 1980?
Keep it short and to the point. -27.43. What is the difference between the Value added (in %) of Burkina Faso in 1978 and the Value added (in %) of Japan in 1980?
Offer a terse response. 7.52. What is the difference between the Value added (in %) of Burkina Faso in 1978 and the Value added (in %) of Paraguay in 1980?
Offer a very short reply. 1.76. What is the difference between the Value added (in %) of Hong Kong in 1978 and the Value added (in %) of Japan in 1980?
Provide a succinct answer. 36.48. What is the difference between the Value added (in %) of Hong Kong in 1978 and the Value added (in %) of Paraguay in 1980?
Provide a short and direct response. 30.71. What is the difference between the Value added (in %) in Japan in 1978 and the Value added (in %) in Paraguay in 1980?
Provide a succinct answer. -4.98. What is the difference between the Value added (in %) in Burkina Faso in 1978 and the Value added (in %) in Hong Kong in 1981?
Your response must be concise. -24.05. What is the difference between the Value added (in %) in Burkina Faso in 1978 and the Value added (in %) in Japan in 1981?
Offer a terse response. 7.83. What is the difference between the Value added (in %) in Burkina Faso in 1978 and the Value added (in %) in Paraguay in 1981?
Offer a terse response. 0. What is the difference between the Value added (in %) of Hong Kong in 1978 and the Value added (in %) of Japan in 1981?
Make the answer very short. 36.78. What is the difference between the Value added (in %) in Hong Kong in 1978 and the Value added (in %) in Paraguay in 1981?
Your response must be concise. 28.96. What is the difference between the Value added (in %) of Japan in 1978 and the Value added (in %) of Paraguay in 1981?
Offer a terse response. -6.73. What is the difference between the Value added (in %) of Burkina Faso in 1979 and the Value added (in %) of Hong Kong in 1980?
Ensure brevity in your answer.  -26.43. What is the difference between the Value added (in %) of Burkina Faso in 1979 and the Value added (in %) of Japan in 1980?
Your response must be concise. 8.53. What is the difference between the Value added (in %) in Burkina Faso in 1979 and the Value added (in %) in Paraguay in 1980?
Your response must be concise. 2.76. What is the difference between the Value added (in %) in Hong Kong in 1979 and the Value added (in %) in Japan in 1980?
Give a very brief answer. 35.16. What is the difference between the Value added (in %) of Hong Kong in 1979 and the Value added (in %) of Paraguay in 1980?
Your answer should be compact. 29.39. What is the difference between the Value added (in %) of Japan in 1979 and the Value added (in %) of Paraguay in 1980?
Make the answer very short. -5.25. What is the difference between the Value added (in %) of Burkina Faso in 1979 and the Value added (in %) of Hong Kong in 1981?
Your response must be concise. -23.05. What is the difference between the Value added (in %) in Burkina Faso in 1979 and the Value added (in %) in Japan in 1981?
Offer a terse response. 8.83. What is the difference between the Value added (in %) of Burkina Faso in 1979 and the Value added (in %) of Paraguay in 1981?
Make the answer very short. 1. What is the difference between the Value added (in %) in Hong Kong in 1979 and the Value added (in %) in Japan in 1981?
Offer a terse response. 35.46. What is the difference between the Value added (in %) in Hong Kong in 1979 and the Value added (in %) in Paraguay in 1981?
Your answer should be compact. 27.64. What is the difference between the Value added (in %) of Japan in 1979 and the Value added (in %) of Paraguay in 1981?
Provide a succinct answer. -7. What is the difference between the Value added (in %) of Burkina Faso in 1980 and the Value added (in %) of Hong Kong in 1981?
Keep it short and to the point. -19.15. What is the difference between the Value added (in %) of Burkina Faso in 1980 and the Value added (in %) of Japan in 1981?
Offer a terse response. 12.73. What is the difference between the Value added (in %) of Burkina Faso in 1980 and the Value added (in %) of Paraguay in 1981?
Make the answer very short. 4.91. What is the difference between the Value added (in %) in Hong Kong in 1980 and the Value added (in %) in Japan in 1981?
Your answer should be compact. 35.26. What is the difference between the Value added (in %) in Hong Kong in 1980 and the Value added (in %) in Paraguay in 1981?
Your response must be concise. 27.44. What is the difference between the Value added (in %) in Japan in 1980 and the Value added (in %) in Paraguay in 1981?
Ensure brevity in your answer.  -7.52. What is the average Value added (in %) in Burkina Faso per year?
Ensure brevity in your answer.  15.26. What is the average Value added (in %) of Hong Kong per year?
Offer a very short reply. 43.59. What is the average Value added (in %) in Japan per year?
Provide a short and direct response. 7.26. What is the average Value added (in %) of Paraguay per year?
Make the answer very short. 16.46. In the year 1974, what is the difference between the Value added (in %) of Burkina Faso and Value added (in %) of Hong Kong?
Offer a very short reply. -30.93. In the year 1974, what is the difference between the Value added (in %) of Burkina Faso and Value added (in %) of Japan?
Give a very brief answer. 6.1. In the year 1974, what is the difference between the Value added (in %) of Burkina Faso and Value added (in %) of Paraguay?
Your answer should be very brief. -3.42. In the year 1974, what is the difference between the Value added (in %) of Hong Kong and Value added (in %) of Japan?
Give a very brief answer. 37.04. In the year 1974, what is the difference between the Value added (in %) in Hong Kong and Value added (in %) in Paraguay?
Your response must be concise. 27.51. In the year 1974, what is the difference between the Value added (in %) of Japan and Value added (in %) of Paraguay?
Give a very brief answer. -9.53. In the year 1975, what is the difference between the Value added (in %) in Burkina Faso and Value added (in %) in Hong Kong?
Provide a succinct answer. -33.97. In the year 1975, what is the difference between the Value added (in %) of Burkina Faso and Value added (in %) of Japan?
Your answer should be compact. 5.58. In the year 1975, what is the difference between the Value added (in %) in Burkina Faso and Value added (in %) in Paraguay?
Keep it short and to the point. -0.9. In the year 1975, what is the difference between the Value added (in %) in Hong Kong and Value added (in %) in Japan?
Your answer should be very brief. 39.54. In the year 1975, what is the difference between the Value added (in %) of Hong Kong and Value added (in %) of Paraguay?
Your answer should be compact. 33.07. In the year 1975, what is the difference between the Value added (in %) of Japan and Value added (in %) of Paraguay?
Offer a very short reply. -6.47. In the year 1976, what is the difference between the Value added (in %) in Burkina Faso and Value added (in %) in Hong Kong?
Provide a short and direct response. -34.41. In the year 1976, what is the difference between the Value added (in %) in Burkina Faso and Value added (in %) in Japan?
Your answer should be compact. 5.87. In the year 1976, what is the difference between the Value added (in %) in Burkina Faso and Value added (in %) in Paraguay?
Provide a succinct answer. -1.84. In the year 1976, what is the difference between the Value added (in %) in Hong Kong and Value added (in %) in Japan?
Ensure brevity in your answer.  40.27. In the year 1976, what is the difference between the Value added (in %) of Hong Kong and Value added (in %) of Paraguay?
Ensure brevity in your answer.  32.57. In the year 1976, what is the difference between the Value added (in %) of Japan and Value added (in %) of Paraguay?
Keep it short and to the point. -7.71. In the year 1977, what is the difference between the Value added (in %) of Burkina Faso and Value added (in %) of Hong Kong?
Give a very brief answer. -30.02. In the year 1977, what is the difference between the Value added (in %) of Burkina Faso and Value added (in %) of Japan?
Your answer should be compact. 6.57. In the year 1977, what is the difference between the Value added (in %) in Burkina Faso and Value added (in %) in Paraguay?
Your answer should be compact. -6.3. In the year 1977, what is the difference between the Value added (in %) of Hong Kong and Value added (in %) of Japan?
Your answer should be compact. 36.59. In the year 1977, what is the difference between the Value added (in %) of Hong Kong and Value added (in %) of Paraguay?
Provide a short and direct response. 23.73. In the year 1977, what is the difference between the Value added (in %) of Japan and Value added (in %) of Paraguay?
Your response must be concise. -12.87. In the year 1978, what is the difference between the Value added (in %) in Burkina Faso and Value added (in %) in Hong Kong?
Your answer should be compact. -28.95. In the year 1978, what is the difference between the Value added (in %) of Burkina Faso and Value added (in %) of Japan?
Keep it short and to the point. 6.73. In the year 1978, what is the difference between the Value added (in %) of Burkina Faso and Value added (in %) of Paraguay?
Your answer should be very brief. -6.97. In the year 1978, what is the difference between the Value added (in %) of Hong Kong and Value added (in %) of Japan?
Give a very brief answer. 35.69. In the year 1978, what is the difference between the Value added (in %) in Hong Kong and Value added (in %) in Paraguay?
Offer a terse response. 21.98. In the year 1978, what is the difference between the Value added (in %) of Japan and Value added (in %) of Paraguay?
Keep it short and to the point. -13.71. In the year 1979, what is the difference between the Value added (in %) of Burkina Faso and Value added (in %) of Hong Kong?
Offer a very short reply. -26.64. In the year 1979, what is the difference between the Value added (in %) of Burkina Faso and Value added (in %) of Japan?
Keep it short and to the point. 8.01. In the year 1979, what is the difference between the Value added (in %) in Burkina Faso and Value added (in %) in Paraguay?
Your answer should be compact. -1.75. In the year 1979, what is the difference between the Value added (in %) in Hong Kong and Value added (in %) in Japan?
Provide a short and direct response. 34.64. In the year 1979, what is the difference between the Value added (in %) in Hong Kong and Value added (in %) in Paraguay?
Your response must be concise. 24.88. In the year 1979, what is the difference between the Value added (in %) of Japan and Value added (in %) of Paraguay?
Ensure brevity in your answer.  -9.76. In the year 1980, what is the difference between the Value added (in %) in Burkina Faso and Value added (in %) in Hong Kong?
Your answer should be very brief. -22.53. In the year 1980, what is the difference between the Value added (in %) in Burkina Faso and Value added (in %) in Japan?
Provide a succinct answer. 12.43. In the year 1980, what is the difference between the Value added (in %) of Burkina Faso and Value added (in %) of Paraguay?
Your answer should be very brief. 6.66. In the year 1980, what is the difference between the Value added (in %) in Hong Kong and Value added (in %) in Japan?
Offer a very short reply. 34.96. In the year 1980, what is the difference between the Value added (in %) in Hong Kong and Value added (in %) in Paraguay?
Make the answer very short. 29.19. In the year 1980, what is the difference between the Value added (in %) of Japan and Value added (in %) of Paraguay?
Offer a very short reply. -5.77. In the year 1981, what is the difference between the Value added (in %) in Burkina Faso and Value added (in %) in Hong Kong?
Give a very brief answer. -19.13. In the year 1981, what is the difference between the Value added (in %) in Burkina Faso and Value added (in %) in Japan?
Provide a succinct answer. 12.74. In the year 1981, what is the difference between the Value added (in %) in Burkina Faso and Value added (in %) in Paraguay?
Give a very brief answer. 4.92. In the year 1981, what is the difference between the Value added (in %) of Hong Kong and Value added (in %) of Japan?
Keep it short and to the point. 31.87. In the year 1981, what is the difference between the Value added (in %) in Hong Kong and Value added (in %) in Paraguay?
Give a very brief answer. 24.05. In the year 1981, what is the difference between the Value added (in %) of Japan and Value added (in %) of Paraguay?
Your response must be concise. -7.82. What is the ratio of the Value added (in %) of Hong Kong in 1974 to that in 1975?
Provide a short and direct response. 0.94. What is the ratio of the Value added (in %) of Japan in 1974 to that in 1975?
Your answer should be compact. 0.93. What is the ratio of the Value added (in %) of Paraguay in 1974 to that in 1975?
Keep it short and to the point. 1.18. What is the ratio of the Value added (in %) in Burkina Faso in 1974 to that in 1976?
Your response must be concise. 0.97. What is the ratio of the Value added (in %) in Hong Kong in 1974 to that in 1976?
Provide a succinct answer. 0.92. What is the ratio of the Value added (in %) of Japan in 1974 to that in 1976?
Offer a very short reply. 0.91. What is the ratio of the Value added (in %) in Paraguay in 1974 to that in 1976?
Your response must be concise. 1.07. What is the ratio of the Value added (in %) of Burkina Faso in 1974 to that in 1977?
Provide a short and direct response. 0.96. What is the ratio of the Value added (in %) in Hong Kong in 1974 to that in 1977?
Ensure brevity in your answer.  1.01. What is the ratio of the Value added (in %) of Japan in 1974 to that in 1977?
Ensure brevity in your answer.  0.99. What is the ratio of the Value added (in %) in Paraguay in 1974 to that in 1977?
Ensure brevity in your answer.  0.83. What is the ratio of the Value added (in %) of Burkina Faso in 1974 to that in 1978?
Offer a terse response. 0.96. What is the ratio of the Value added (in %) in Hong Kong in 1974 to that in 1978?
Offer a terse response. 1.03. What is the ratio of the Value added (in %) of Paraguay in 1974 to that in 1978?
Provide a short and direct response. 0.8. What is the ratio of the Value added (in %) of Burkina Faso in 1974 to that in 1979?
Provide a short and direct response. 0.89. What is the ratio of the Value added (in %) of Hong Kong in 1974 to that in 1979?
Your response must be concise. 1.06. What is the ratio of the Value added (in %) of Japan in 1974 to that in 1979?
Your response must be concise. 1.04. What is the ratio of the Value added (in %) in Paraguay in 1974 to that in 1979?
Keep it short and to the point. 1. What is the ratio of the Value added (in %) in Burkina Faso in 1974 to that in 1980?
Your answer should be very brief. 0.71. What is the ratio of the Value added (in %) in Hong Kong in 1974 to that in 1980?
Ensure brevity in your answer.  1.07. What is the ratio of the Value added (in %) in Japan in 1974 to that in 1980?
Your answer should be very brief. 1.12. What is the ratio of the Value added (in %) in Paraguay in 1974 to that in 1980?
Your response must be concise. 1.37. What is the ratio of the Value added (in %) of Burkina Faso in 1974 to that in 1981?
Provide a succinct answer. 0.71. What is the ratio of the Value added (in %) in Hong Kong in 1974 to that in 1981?
Provide a succinct answer. 1.16. What is the ratio of the Value added (in %) in Japan in 1974 to that in 1981?
Your response must be concise. 1.18. What is the ratio of the Value added (in %) in Paraguay in 1974 to that in 1981?
Make the answer very short. 1.2. What is the ratio of the Value added (in %) in Burkina Faso in 1975 to that in 1976?
Keep it short and to the point. 0.97. What is the ratio of the Value added (in %) in Japan in 1975 to that in 1976?
Make the answer very short. 0.98. What is the ratio of the Value added (in %) in Paraguay in 1975 to that in 1976?
Your answer should be very brief. 0.91. What is the ratio of the Value added (in %) in Hong Kong in 1975 to that in 1977?
Offer a terse response. 1.08. What is the ratio of the Value added (in %) in Japan in 1975 to that in 1977?
Your response must be concise. 1.07. What is the ratio of the Value added (in %) of Paraguay in 1975 to that in 1977?
Ensure brevity in your answer.  0.71. What is the ratio of the Value added (in %) in Burkina Faso in 1975 to that in 1978?
Make the answer very short. 0.96. What is the ratio of the Value added (in %) in Hong Kong in 1975 to that in 1978?
Give a very brief answer. 1.1. What is the ratio of the Value added (in %) in Japan in 1975 to that in 1978?
Provide a succinct answer. 1.07. What is the ratio of the Value added (in %) of Paraguay in 1975 to that in 1978?
Offer a terse response. 0.68. What is the ratio of the Value added (in %) in Burkina Faso in 1975 to that in 1979?
Your answer should be very brief. 0.89. What is the ratio of the Value added (in %) of Hong Kong in 1975 to that in 1979?
Your response must be concise. 1.14. What is the ratio of the Value added (in %) of Japan in 1975 to that in 1979?
Give a very brief answer. 1.11. What is the ratio of the Value added (in %) of Paraguay in 1975 to that in 1979?
Make the answer very short. 0.85. What is the ratio of the Value added (in %) in Burkina Faso in 1975 to that in 1980?
Keep it short and to the point. 0.71. What is the ratio of the Value added (in %) of Hong Kong in 1975 to that in 1980?
Your response must be concise. 1.14. What is the ratio of the Value added (in %) in Japan in 1975 to that in 1980?
Provide a succinct answer. 1.2. What is the ratio of the Value added (in %) of Paraguay in 1975 to that in 1980?
Provide a succinct answer. 1.16. What is the ratio of the Value added (in %) in Burkina Faso in 1975 to that in 1981?
Provide a succinct answer. 0.71. What is the ratio of the Value added (in %) in Hong Kong in 1975 to that in 1981?
Your answer should be compact. 1.24. What is the ratio of the Value added (in %) in Japan in 1975 to that in 1981?
Keep it short and to the point. 1.26. What is the ratio of the Value added (in %) of Paraguay in 1975 to that in 1981?
Your answer should be very brief. 1.02. What is the ratio of the Value added (in %) in Burkina Faso in 1976 to that in 1977?
Provide a short and direct response. 1. What is the ratio of the Value added (in %) in Hong Kong in 1976 to that in 1977?
Your answer should be very brief. 1.1. What is the ratio of the Value added (in %) of Japan in 1976 to that in 1977?
Your answer should be very brief. 1.09. What is the ratio of the Value added (in %) of Paraguay in 1976 to that in 1977?
Your answer should be very brief. 0.78. What is the ratio of the Value added (in %) of Burkina Faso in 1976 to that in 1978?
Your answer should be very brief. 0.99. What is the ratio of the Value added (in %) of Hong Kong in 1976 to that in 1978?
Give a very brief answer. 1.12. What is the ratio of the Value added (in %) of Japan in 1976 to that in 1978?
Offer a very short reply. 1.1. What is the ratio of the Value added (in %) in Paraguay in 1976 to that in 1978?
Your answer should be compact. 0.75. What is the ratio of the Value added (in %) of Burkina Faso in 1976 to that in 1979?
Your answer should be compact. 0.92. What is the ratio of the Value added (in %) in Hong Kong in 1976 to that in 1979?
Provide a succinct answer. 1.16. What is the ratio of the Value added (in %) in Japan in 1976 to that in 1979?
Your answer should be very brief. 1.14. What is the ratio of the Value added (in %) in Burkina Faso in 1976 to that in 1980?
Offer a terse response. 0.73. What is the ratio of the Value added (in %) of Hong Kong in 1976 to that in 1980?
Your answer should be compact. 1.16. What is the ratio of the Value added (in %) in Japan in 1976 to that in 1980?
Make the answer very short. 1.23. What is the ratio of the Value added (in %) in Paraguay in 1976 to that in 1980?
Make the answer very short. 1.28. What is the ratio of the Value added (in %) of Burkina Faso in 1976 to that in 1981?
Your answer should be compact. 0.73. What is the ratio of the Value added (in %) of Hong Kong in 1976 to that in 1981?
Make the answer very short. 1.27. What is the ratio of the Value added (in %) in Japan in 1976 to that in 1981?
Your answer should be compact. 1.29. What is the ratio of the Value added (in %) of Paraguay in 1976 to that in 1981?
Keep it short and to the point. 1.12. What is the ratio of the Value added (in %) of Burkina Faso in 1977 to that in 1978?
Offer a very short reply. 0.99. What is the ratio of the Value added (in %) in Hong Kong in 1977 to that in 1978?
Provide a short and direct response. 1.02. What is the ratio of the Value added (in %) in Japan in 1977 to that in 1978?
Your answer should be very brief. 1.01. What is the ratio of the Value added (in %) of Paraguay in 1977 to that in 1978?
Give a very brief answer. 0.96. What is the ratio of the Value added (in %) in Burkina Faso in 1977 to that in 1979?
Provide a succinct answer. 0.93. What is the ratio of the Value added (in %) in Hong Kong in 1977 to that in 1979?
Your answer should be compact. 1.05. What is the ratio of the Value added (in %) of Japan in 1977 to that in 1979?
Provide a short and direct response. 1.04. What is the ratio of the Value added (in %) in Paraguay in 1977 to that in 1979?
Provide a short and direct response. 1.2. What is the ratio of the Value added (in %) in Burkina Faso in 1977 to that in 1980?
Your answer should be very brief. 0.74. What is the ratio of the Value added (in %) of Hong Kong in 1977 to that in 1980?
Keep it short and to the point. 1.06. What is the ratio of the Value added (in %) of Japan in 1977 to that in 1980?
Offer a terse response. 1.13. What is the ratio of the Value added (in %) in Paraguay in 1977 to that in 1980?
Offer a very short reply. 1.64. What is the ratio of the Value added (in %) in Burkina Faso in 1977 to that in 1981?
Your response must be concise. 0.74. What is the ratio of the Value added (in %) of Hong Kong in 1977 to that in 1981?
Provide a short and direct response. 1.15. What is the ratio of the Value added (in %) of Japan in 1977 to that in 1981?
Keep it short and to the point. 1.18. What is the ratio of the Value added (in %) of Paraguay in 1977 to that in 1981?
Your answer should be very brief. 1.44. What is the ratio of the Value added (in %) of Burkina Faso in 1978 to that in 1979?
Your response must be concise. 0.93. What is the ratio of the Value added (in %) of Hong Kong in 1978 to that in 1979?
Your response must be concise. 1.03. What is the ratio of the Value added (in %) of Japan in 1978 to that in 1979?
Your answer should be very brief. 1.04. What is the ratio of the Value added (in %) in Paraguay in 1978 to that in 1979?
Your response must be concise. 1.25. What is the ratio of the Value added (in %) in Burkina Faso in 1978 to that in 1980?
Make the answer very short. 0.74. What is the ratio of the Value added (in %) of Hong Kong in 1978 to that in 1980?
Offer a very short reply. 1.04. What is the ratio of the Value added (in %) in Japan in 1978 to that in 1980?
Ensure brevity in your answer.  1.12. What is the ratio of the Value added (in %) in Paraguay in 1978 to that in 1980?
Ensure brevity in your answer.  1.71. What is the ratio of the Value added (in %) in Burkina Faso in 1978 to that in 1981?
Keep it short and to the point. 0.74. What is the ratio of the Value added (in %) of Hong Kong in 1978 to that in 1981?
Provide a succinct answer. 1.13. What is the ratio of the Value added (in %) in Japan in 1978 to that in 1981?
Provide a succinct answer. 1.17. What is the ratio of the Value added (in %) of Paraguay in 1978 to that in 1981?
Provide a succinct answer. 1.49. What is the ratio of the Value added (in %) in Burkina Faso in 1979 to that in 1980?
Offer a very short reply. 0.79. What is the ratio of the Value added (in %) of Hong Kong in 1979 to that in 1980?
Make the answer very short. 1. What is the ratio of the Value added (in %) of Japan in 1979 to that in 1980?
Provide a short and direct response. 1.08. What is the ratio of the Value added (in %) of Paraguay in 1979 to that in 1980?
Offer a terse response. 1.37. What is the ratio of the Value added (in %) of Burkina Faso in 1979 to that in 1981?
Your answer should be very brief. 0.79. What is the ratio of the Value added (in %) in Hong Kong in 1979 to that in 1981?
Offer a terse response. 1.09. What is the ratio of the Value added (in %) in Japan in 1979 to that in 1981?
Keep it short and to the point. 1.13. What is the ratio of the Value added (in %) of Paraguay in 1979 to that in 1981?
Keep it short and to the point. 1.2. What is the ratio of the Value added (in %) of Burkina Faso in 1980 to that in 1981?
Ensure brevity in your answer.  1. What is the ratio of the Value added (in %) of Hong Kong in 1980 to that in 1981?
Offer a terse response. 1.09. What is the ratio of the Value added (in %) in Japan in 1980 to that in 1981?
Your response must be concise. 1.05. What is the ratio of the Value added (in %) in Paraguay in 1980 to that in 1981?
Ensure brevity in your answer.  0.88. What is the difference between the highest and the second highest Value added (in %) of Burkina Faso?
Offer a very short reply. 0.01. What is the difference between the highest and the second highest Value added (in %) in Hong Kong?
Make the answer very short. 0.92. What is the difference between the highest and the second highest Value added (in %) of Japan?
Offer a very short reply. 0.19. What is the difference between the highest and the second highest Value added (in %) in Paraguay?
Your answer should be compact. 0.79. What is the difference between the highest and the lowest Value added (in %) in Burkina Faso?
Offer a very short reply. 5.54. What is the difference between the highest and the lowest Value added (in %) of Hong Kong?
Provide a short and direct response. 10.22. What is the difference between the highest and the lowest Value added (in %) of Japan?
Provide a short and direct response. 1.82. What is the difference between the highest and the lowest Value added (in %) of Paraguay?
Your answer should be very brief. 8.73. 